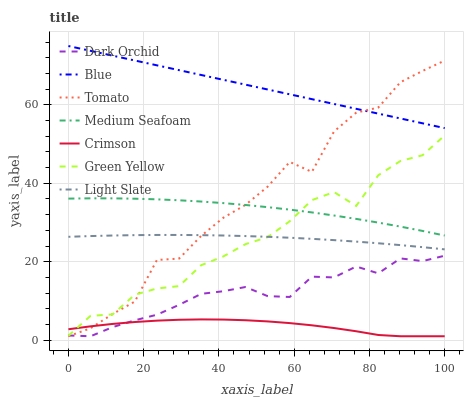Does Crimson have the minimum area under the curve?
Answer yes or no. Yes. Does Blue have the maximum area under the curve?
Answer yes or no. Yes. Does Tomato have the minimum area under the curve?
Answer yes or no. No. Does Tomato have the maximum area under the curve?
Answer yes or no. No. Is Blue the smoothest?
Answer yes or no. Yes. Is Tomato the roughest?
Answer yes or no. Yes. Is Light Slate the smoothest?
Answer yes or no. No. Is Light Slate the roughest?
Answer yes or no. No. Does Tomato have the lowest value?
Answer yes or no. Yes. Does Light Slate have the lowest value?
Answer yes or no. No. Does Blue have the highest value?
Answer yes or no. Yes. Does Tomato have the highest value?
Answer yes or no. No. Is Light Slate less than Medium Seafoam?
Answer yes or no. Yes. Is Medium Seafoam greater than Dark Orchid?
Answer yes or no. Yes. Does Crimson intersect Green Yellow?
Answer yes or no. Yes. Is Crimson less than Green Yellow?
Answer yes or no. No. Is Crimson greater than Green Yellow?
Answer yes or no. No. Does Light Slate intersect Medium Seafoam?
Answer yes or no. No. 